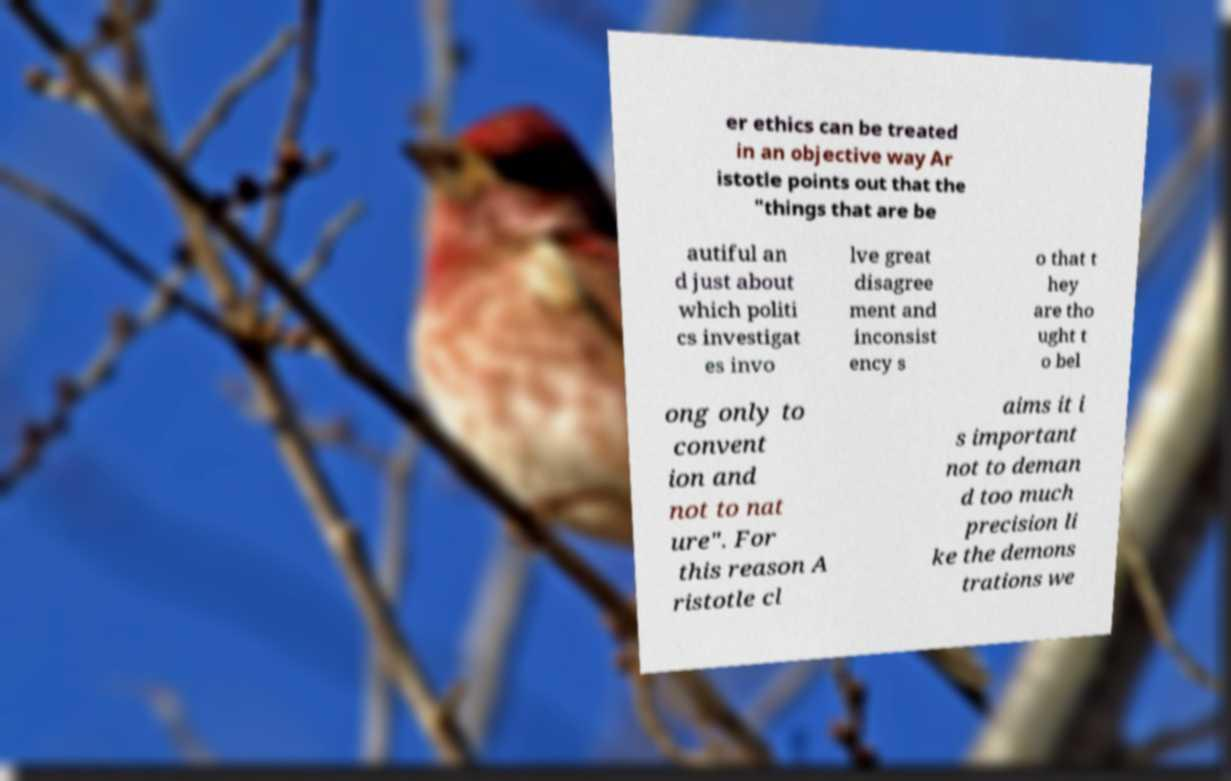Could you assist in decoding the text presented in this image and type it out clearly? er ethics can be treated in an objective way Ar istotle points out that the "things that are be autiful an d just about which politi cs investigat es invo lve great disagree ment and inconsist ency s o that t hey are tho ught t o bel ong only to convent ion and not to nat ure". For this reason A ristotle cl aims it i s important not to deman d too much precision li ke the demons trations we 